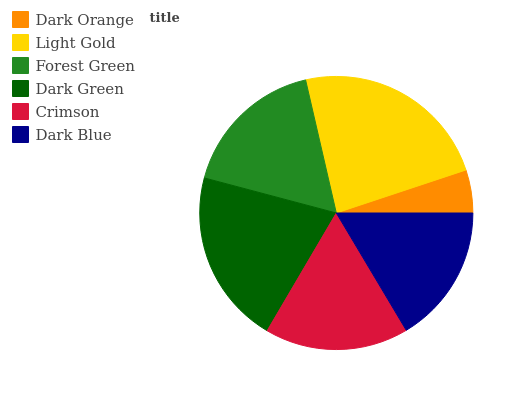Is Dark Orange the minimum?
Answer yes or no. Yes. Is Light Gold the maximum?
Answer yes or no. Yes. Is Forest Green the minimum?
Answer yes or no. No. Is Forest Green the maximum?
Answer yes or no. No. Is Light Gold greater than Forest Green?
Answer yes or no. Yes. Is Forest Green less than Light Gold?
Answer yes or no. Yes. Is Forest Green greater than Light Gold?
Answer yes or no. No. Is Light Gold less than Forest Green?
Answer yes or no. No. Is Forest Green the high median?
Answer yes or no. Yes. Is Crimson the low median?
Answer yes or no. Yes. Is Dark Orange the high median?
Answer yes or no. No. Is Light Gold the low median?
Answer yes or no. No. 